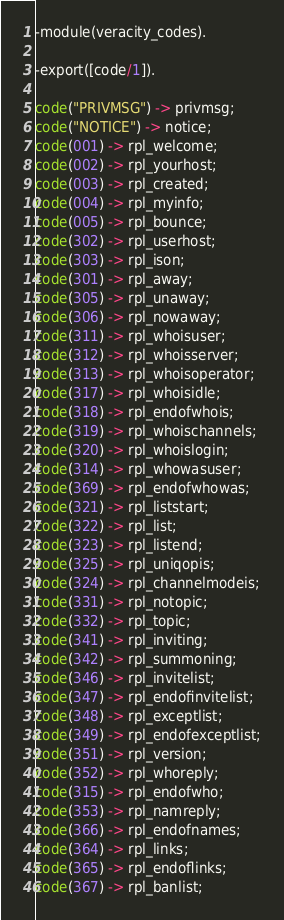<code> <loc_0><loc_0><loc_500><loc_500><_Erlang_>-module(veracity_codes).

-export([code/1]).

code("PRIVMSG") -> privmsg;
code("NOTICE") -> notice;
code(001) -> rpl_welcome;
code(002) -> rpl_yourhost;
code(003) -> rpl_created;
code(004) -> rpl_myinfo;
code(005) -> rpl_bounce;
code(302) -> rpl_userhost;
code(303) -> rpl_ison;
code(301) -> rpl_away;
code(305) -> rpl_unaway;
code(306) -> rpl_nowaway;
code(311) -> rpl_whoisuser;
code(312) -> rpl_whoisserver;
code(313) -> rpl_whoisoperator;
code(317) -> rpl_whoisidle;
code(318) -> rpl_endofwhois;
code(319) -> rpl_whoischannels;
code(320) -> rpl_whoislogin;
code(314) -> rpl_whowasuser;
code(369) -> rpl_endofwhowas;
code(321) -> rpl_liststart;
code(322) -> rpl_list;
code(323) -> rpl_listend;
code(325) -> rpl_uniqopis;
code(324) -> rpl_channelmodeis;
code(331) -> rpl_notopic;
code(332) -> rpl_topic;
code(341) -> rpl_inviting;
code(342) -> rpl_summoning;
code(346) -> rpl_invitelist;
code(347) -> rpl_endofinvitelist;
code(348) -> rpl_exceptlist;
code(349) -> rpl_endofexceptlist;
code(351) -> rpl_version;
code(352) -> rpl_whoreply;
code(315) -> rpl_endofwho;
code(353) -> rpl_namreply;
code(366) -> rpl_endofnames;
code(364) -> rpl_links;
code(365) -> rpl_endoflinks;
code(367) -> rpl_banlist;</code> 